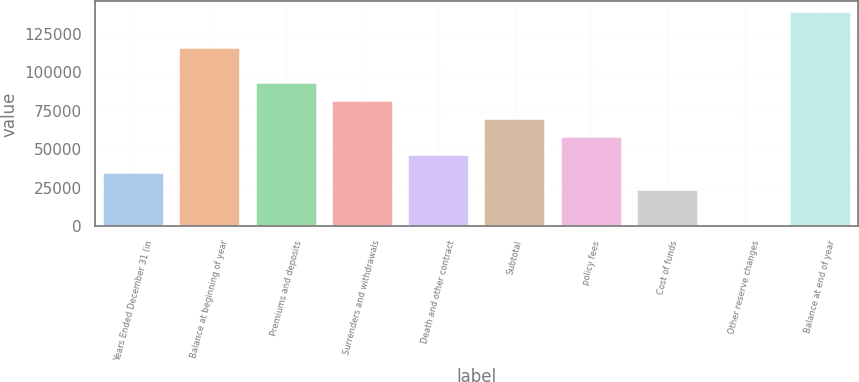Convert chart to OTSL. <chart><loc_0><loc_0><loc_500><loc_500><bar_chart><fcel>Years Ended December 31 (in<fcel>Balance at beginning of year<fcel>Premiums and deposits<fcel>Surrenders and withdrawals<fcel>Death and other contract<fcel>Subtotal<fcel>policy fees<fcel>Cost of funds<fcel>Other reserve changes<fcel>Balance at end of year<nl><fcel>34837.5<fcel>115831<fcel>92690<fcel>81119.5<fcel>46408<fcel>69549<fcel>57978.5<fcel>23267<fcel>126<fcel>138972<nl></chart> 